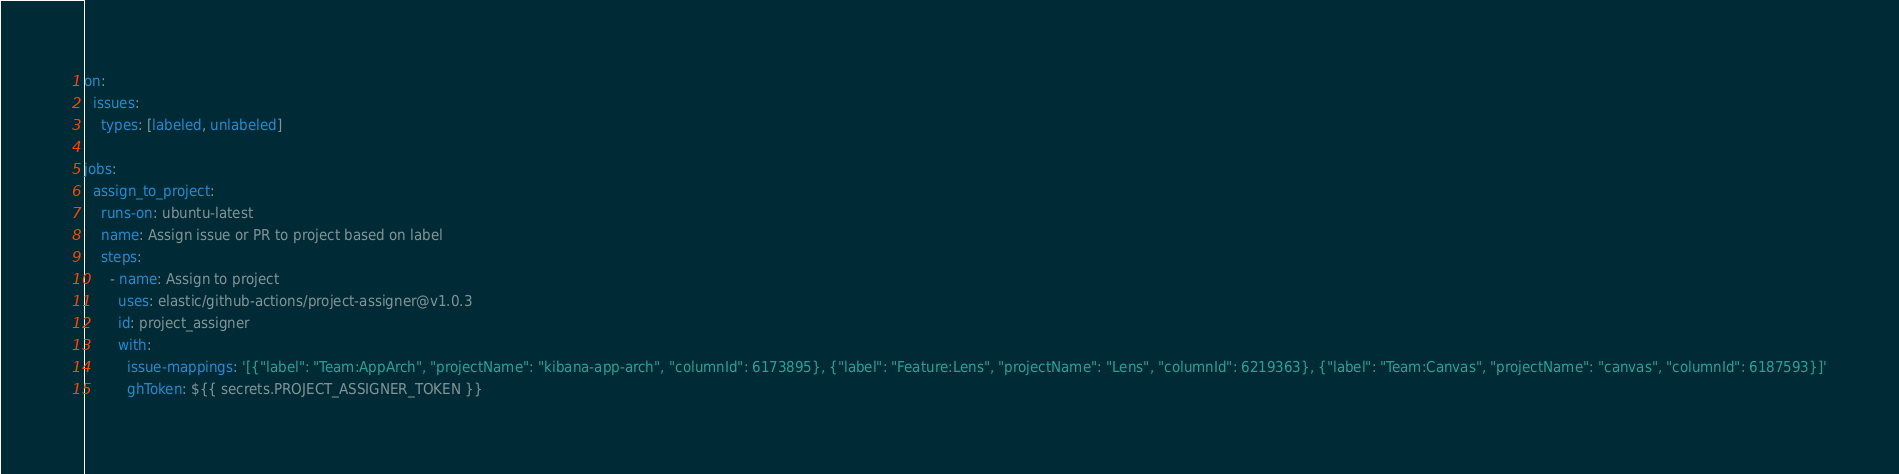Convert code to text. <code><loc_0><loc_0><loc_500><loc_500><_YAML_>on:
  issues:
    types: [labeled, unlabeled]

jobs:
  assign_to_project:
    runs-on: ubuntu-latest
    name: Assign issue or PR to project based on label
    steps:
      - name: Assign to project
        uses: elastic/github-actions/project-assigner@v1.0.3
        id: project_assigner
        with:
          issue-mappings: '[{"label": "Team:AppArch", "projectName": "kibana-app-arch", "columnId": 6173895}, {"label": "Feature:Lens", "projectName": "Lens", "columnId": 6219363}, {"label": "Team:Canvas", "projectName": "canvas", "columnId": 6187593}]'
          ghToken: ${{ secrets.PROJECT_ASSIGNER_TOKEN }}


</code> 